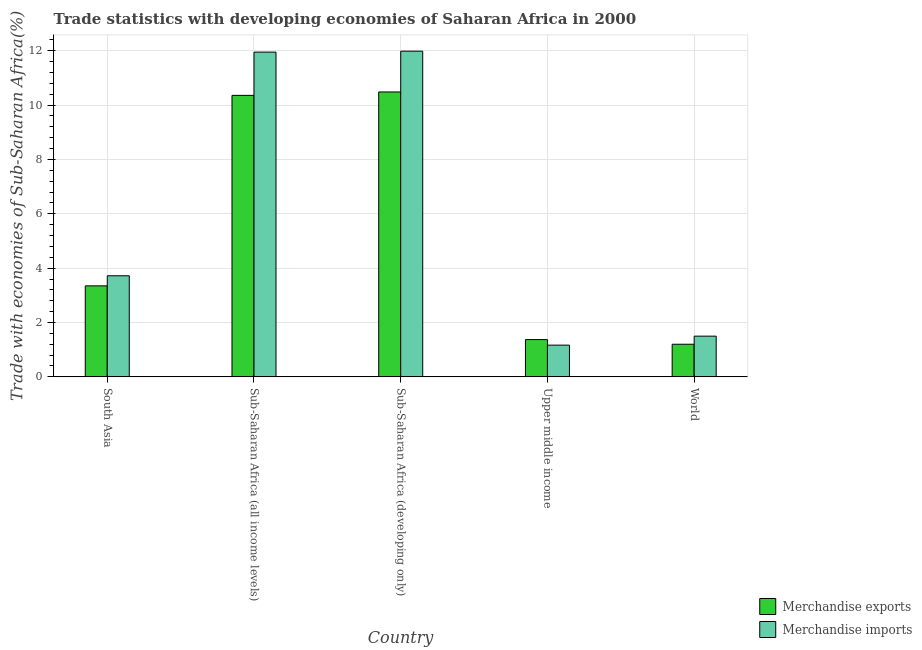How many bars are there on the 1st tick from the right?
Your answer should be very brief. 2. In how many cases, is the number of bars for a given country not equal to the number of legend labels?
Provide a succinct answer. 0. What is the merchandise exports in Sub-Saharan Africa (all income levels)?
Your answer should be very brief. 10.36. Across all countries, what is the maximum merchandise imports?
Ensure brevity in your answer.  11.98. Across all countries, what is the minimum merchandise exports?
Keep it short and to the point. 1.2. In which country was the merchandise imports maximum?
Keep it short and to the point. Sub-Saharan Africa (developing only). In which country was the merchandise exports minimum?
Keep it short and to the point. World. What is the total merchandise exports in the graph?
Offer a very short reply. 26.76. What is the difference between the merchandise imports in Sub-Saharan Africa (all income levels) and that in Sub-Saharan Africa (developing only)?
Offer a terse response. -0.03. What is the difference between the merchandise imports in Sub-Saharan Africa (developing only) and the merchandise exports in Upper middle income?
Ensure brevity in your answer.  10.61. What is the average merchandise exports per country?
Your answer should be very brief. 5.35. What is the difference between the merchandise imports and merchandise exports in Sub-Saharan Africa (developing only)?
Offer a very short reply. 1.5. In how many countries, is the merchandise imports greater than 2.8 %?
Keep it short and to the point. 3. What is the ratio of the merchandise exports in South Asia to that in Upper middle income?
Your response must be concise. 2.44. Is the merchandise exports in Sub-Saharan Africa (all income levels) less than that in Sub-Saharan Africa (developing only)?
Provide a short and direct response. Yes. Is the difference between the merchandise imports in Sub-Saharan Africa (all income levels) and Sub-Saharan Africa (developing only) greater than the difference between the merchandise exports in Sub-Saharan Africa (all income levels) and Sub-Saharan Africa (developing only)?
Your answer should be very brief. Yes. What is the difference between the highest and the second highest merchandise imports?
Keep it short and to the point. 0.03. What is the difference between the highest and the lowest merchandise exports?
Your answer should be compact. 9.28. What does the 2nd bar from the right in Sub-Saharan Africa (all income levels) represents?
Give a very brief answer. Merchandise exports. How many bars are there?
Your answer should be very brief. 10. Are all the bars in the graph horizontal?
Give a very brief answer. No. Does the graph contain any zero values?
Your answer should be compact. No. What is the title of the graph?
Offer a very short reply. Trade statistics with developing economies of Saharan Africa in 2000. Does "Girls" appear as one of the legend labels in the graph?
Ensure brevity in your answer.  No. What is the label or title of the X-axis?
Your response must be concise. Country. What is the label or title of the Y-axis?
Make the answer very short. Trade with economies of Sub-Saharan Africa(%). What is the Trade with economies of Sub-Saharan Africa(%) of Merchandise exports in South Asia?
Provide a short and direct response. 3.35. What is the Trade with economies of Sub-Saharan Africa(%) in Merchandise imports in South Asia?
Provide a succinct answer. 3.72. What is the Trade with economies of Sub-Saharan Africa(%) in Merchandise exports in Sub-Saharan Africa (all income levels)?
Keep it short and to the point. 10.36. What is the Trade with economies of Sub-Saharan Africa(%) in Merchandise imports in Sub-Saharan Africa (all income levels)?
Offer a very short reply. 11.95. What is the Trade with economies of Sub-Saharan Africa(%) of Merchandise exports in Sub-Saharan Africa (developing only)?
Keep it short and to the point. 10.48. What is the Trade with economies of Sub-Saharan Africa(%) in Merchandise imports in Sub-Saharan Africa (developing only)?
Give a very brief answer. 11.98. What is the Trade with economies of Sub-Saharan Africa(%) of Merchandise exports in Upper middle income?
Give a very brief answer. 1.37. What is the Trade with economies of Sub-Saharan Africa(%) of Merchandise imports in Upper middle income?
Offer a very short reply. 1.17. What is the Trade with economies of Sub-Saharan Africa(%) in Merchandise exports in World?
Keep it short and to the point. 1.2. What is the Trade with economies of Sub-Saharan Africa(%) of Merchandise imports in World?
Ensure brevity in your answer.  1.5. Across all countries, what is the maximum Trade with economies of Sub-Saharan Africa(%) of Merchandise exports?
Offer a very short reply. 10.48. Across all countries, what is the maximum Trade with economies of Sub-Saharan Africa(%) of Merchandise imports?
Give a very brief answer. 11.98. Across all countries, what is the minimum Trade with economies of Sub-Saharan Africa(%) of Merchandise exports?
Keep it short and to the point. 1.2. Across all countries, what is the minimum Trade with economies of Sub-Saharan Africa(%) in Merchandise imports?
Your response must be concise. 1.17. What is the total Trade with economies of Sub-Saharan Africa(%) in Merchandise exports in the graph?
Your answer should be very brief. 26.76. What is the total Trade with economies of Sub-Saharan Africa(%) of Merchandise imports in the graph?
Offer a very short reply. 30.32. What is the difference between the Trade with economies of Sub-Saharan Africa(%) of Merchandise exports in South Asia and that in Sub-Saharan Africa (all income levels)?
Provide a succinct answer. -7.01. What is the difference between the Trade with economies of Sub-Saharan Africa(%) of Merchandise imports in South Asia and that in Sub-Saharan Africa (all income levels)?
Provide a succinct answer. -8.23. What is the difference between the Trade with economies of Sub-Saharan Africa(%) of Merchandise exports in South Asia and that in Sub-Saharan Africa (developing only)?
Make the answer very short. -7.13. What is the difference between the Trade with economies of Sub-Saharan Africa(%) of Merchandise imports in South Asia and that in Sub-Saharan Africa (developing only)?
Give a very brief answer. -8.26. What is the difference between the Trade with economies of Sub-Saharan Africa(%) in Merchandise exports in South Asia and that in Upper middle income?
Give a very brief answer. 1.98. What is the difference between the Trade with economies of Sub-Saharan Africa(%) of Merchandise imports in South Asia and that in Upper middle income?
Your response must be concise. 2.55. What is the difference between the Trade with economies of Sub-Saharan Africa(%) in Merchandise exports in South Asia and that in World?
Your answer should be very brief. 2.15. What is the difference between the Trade with economies of Sub-Saharan Africa(%) in Merchandise imports in South Asia and that in World?
Offer a terse response. 2.22. What is the difference between the Trade with economies of Sub-Saharan Africa(%) of Merchandise exports in Sub-Saharan Africa (all income levels) and that in Sub-Saharan Africa (developing only)?
Your answer should be compact. -0.13. What is the difference between the Trade with economies of Sub-Saharan Africa(%) of Merchandise imports in Sub-Saharan Africa (all income levels) and that in Sub-Saharan Africa (developing only)?
Your response must be concise. -0.04. What is the difference between the Trade with economies of Sub-Saharan Africa(%) in Merchandise exports in Sub-Saharan Africa (all income levels) and that in Upper middle income?
Provide a short and direct response. 8.98. What is the difference between the Trade with economies of Sub-Saharan Africa(%) of Merchandise imports in Sub-Saharan Africa (all income levels) and that in Upper middle income?
Offer a very short reply. 10.78. What is the difference between the Trade with economies of Sub-Saharan Africa(%) of Merchandise exports in Sub-Saharan Africa (all income levels) and that in World?
Provide a short and direct response. 9.16. What is the difference between the Trade with economies of Sub-Saharan Africa(%) in Merchandise imports in Sub-Saharan Africa (all income levels) and that in World?
Keep it short and to the point. 10.45. What is the difference between the Trade with economies of Sub-Saharan Africa(%) of Merchandise exports in Sub-Saharan Africa (developing only) and that in Upper middle income?
Provide a short and direct response. 9.11. What is the difference between the Trade with economies of Sub-Saharan Africa(%) in Merchandise imports in Sub-Saharan Africa (developing only) and that in Upper middle income?
Your answer should be very brief. 10.82. What is the difference between the Trade with economies of Sub-Saharan Africa(%) of Merchandise exports in Sub-Saharan Africa (developing only) and that in World?
Provide a short and direct response. 9.28. What is the difference between the Trade with economies of Sub-Saharan Africa(%) of Merchandise imports in Sub-Saharan Africa (developing only) and that in World?
Keep it short and to the point. 10.48. What is the difference between the Trade with economies of Sub-Saharan Africa(%) in Merchandise exports in Upper middle income and that in World?
Offer a terse response. 0.17. What is the difference between the Trade with economies of Sub-Saharan Africa(%) of Merchandise imports in Upper middle income and that in World?
Provide a short and direct response. -0.33. What is the difference between the Trade with economies of Sub-Saharan Africa(%) of Merchandise exports in South Asia and the Trade with economies of Sub-Saharan Africa(%) of Merchandise imports in Sub-Saharan Africa (all income levels)?
Provide a succinct answer. -8.6. What is the difference between the Trade with economies of Sub-Saharan Africa(%) in Merchandise exports in South Asia and the Trade with economies of Sub-Saharan Africa(%) in Merchandise imports in Sub-Saharan Africa (developing only)?
Provide a short and direct response. -8.63. What is the difference between the Trade with economies of Sub-Saharan Africa(%) of Merchandise exports in South Asia and the Trade with economies of Sub-Saharan Africa(%) of Merchandise imports in Upper middle income?
Ensure brevity in your answer.  2.18. What is the difference between the Trade with economies of Sub-Saharan Africa(%) of Merchandise exports in South Asia and the Trade with economies of Sub-Saharan Africa(%) of Merchandise imports in World?
Your answer should be compact. 1.85. What is the difference between the Trade with economies of Sub-Saharan Africa(%) of Merchandise exports in Sub-Saharan Africa (all income levels) and the Trade with economies of Sub-Saharan Africa(%) of Merchandise imports in Sub-Saharan Africa (developing only)?
Offer a very short reply. -1.63. What is the difference between the Trade with economies of Sub-Saharan Africa(%) of Merchandise exports in Sub-Saharan Africa (all income levels) and the Trade with economies of Sub-Saharan Africa(%) of Merchandise imports in Upper middle income?
Make the answer very short. 9.19. What is the difference between the Trade with economies of Sub-Saharan Africa(%) of Merchandise exports in Sub-Saharan Africa (all income levels) and the Trade with economies of Sub-Saharan Africa(%) of Merchandise imports in World?
Provide a succinct answer. 8.86. What is the difference between the Trade with economies of Sub-Saharan Africa(%) of Merchandise exports in Sub-Saharan Africa (developing only) and the Trade with economies of Sub-Saharan Africa(%) of Merchandise imports in Upper middle income?
Your answer should be very brief. 9.31. What is the difference between the Trade with economies of Sub-Saharan Africa(%) in Merchandise exports in Sub-Saharan Africa (developing only) and the Trade with economies of Sub-Saharan Africa(%) in Merchandise imports in World?
Give a very brief answer. 8.98. What is the difference between the Trade with economies of Sub-Saharan Africa(%) of Merchandise exports in Upper middle income and the Trade with economies of Sub-Saharan Africa(%) of Merchandise imports in World?
Offer a very short reply. -0.13. What is the average Trade with economies of Sub-Saharan Africa(%) of Merchandise exports per country?
Ensure brevity in your answer.  5.35. What is the average Trade with economies of Sub-Saharan Africa(%) of Merchandise imports per country?
Provide a succinct answer. 6.06. What is the difference between the Trade with economies of Sub-Saharan Africa(%) in Merchandise exports and Trade with economies of Sub-Saharan Africa(%) in Merchandise imports in South Asia?
Your response must be concise. -0.37. What is the difference between the Trade with economies of Sub-Saharan Africa(%) of Merchandise exports and Trade with economies of Sub-Saharan Africa(%) of Merchandise imports in Sub-Saharan Africa (all income levels)?
Ensure brevity in your answer.  -1.59. What is the difference between the Trade with economies of Sub-Saharan Africa(%) of Merchandise exports and Trade with economies of Sub-Saharan Africa(%) of Merchandise imports in Sub-Saharan Africa (developing only)?
Your answer should be very brief. -1.5. What is the difference between the Trade with economies of Sub-Saharan Africa(%) of Merchandise exports and Trade with economies of Sub-Saharan Africa(%) of Merchandise imports in Upper middle income?
Provide a short and direct response. 0.2. What is the difference between the Trade with economies of Sub-Saharan Africa(%) of Merchandise exports and Trade with economies of Sub-Saharan Africa(%) of Merchandise imports in World?
Make the answer very short. -0.3. What is the ratio of the Trade with economies of Sub-Saharan Africa(%) in Merchandise exports in South Asia to that in Sub-Saharan Africa (all income levels)?
Offer a very short reply. 0.32. What is the ratio of the Trade with economies of Sub-Saharan Africa(%) in Merchandise imports in South Asia to that in Sub-Saharan Africa (all income levels)?
Offer a terse response. 0.31. What is the ratio of the Trade with economies of Sub-Saharan Africa(%) in Merchandise exports in South Asia to that in Sub-Saharan Africa (developing only)?
Offer a terse response. 0.32. What is the ratio of the Trade with economies of Sub-Saharan Africa(%) of Merchandise imports in South Asia to that in Sub-Saharan Africa (developing only)?
Provide a short and direct response. 0.31. What is the ratio of the Trade with economies of Sub-Saharan Africa(%) in Merchandise exports in South Asia to that in Upper middle income?
Your answer should be compact. 2.44. What is the ratio of the Trade with economies of Sub-Saharan Africa(%) of Merchandise imports in South Asia to that in Upper middle income?
Give a very brief answer. 3.19. What is the ratio of the Trade with economies of Sub-Saharan Africa(%) in Merchandise exports in South Asia to that in World?
Provide a succinct answer. 2.79. What is the ratio of the Trade with economies of Sub-Saharan Africa(%) in Merchandise imports in South Asia to that in World?
Your answer should be compact. 2.48. What is the ratio of the Trade with economies of Sub-Saharan Africa(%) of Merchandise exports in Sub-Saharan Africa (all income levels) to that in Sub-Saharan Africa (developing only)?
Your answer should be compact. 0.99. What is the ratio of the Trade with economies of Sub-Saharan Africa(%) in Merchandise imports in Sub-Saharan Africa (all income levels) to that in Sub-Saharan Africa (developing only)?
Your answer should be compact. 1. What is the ratio of the Trade with economies of Sub-Saharan Africa(%) of Merchandise exports in Sub-Saharan Africa (all income levels) to that in Upper middle income?
Keep it short and to the point. 7.55. What is the ratio of the Trade with economies of Sub-Saharan Africa(%) in Merchandise imports in Sub-Saharan Africa (all income levels) to that in Upper middle income?
Provide a succinct answer. 10.23. What is the ratio of the Trade with economies of Sub-Saharan Africa(%) of Merchandise exports in Sub-Saharan Africa (all income levels) to that in World?
Give a very brief answer. 8.63. What is the ratio of the Trade with economies of Sub-Saharan Africa(%) of Merchandise imports in Sub-Saharan Africa (all income levels) to that in World?
Your response must be concise. 7.98. What is the ratio of the Trade with economies of Sub-Saharan Africa(%) of Merchandise exports in Sub-Saharan Africa (developing only) to that in Upper middle income?
Keep it short and to the point. 7.64. What is the ratio of the Trade with economies of Sub-Saharan Africa(%) of Merchandise imports in Sub-Saharan Africa (developing only) to that in Upper middle income?
Provide a short and direct response. 10.26. What is the ratio of the Trade with economies of Sub-Saharan Africa(%) in Merchandise exports in Sub-Saharan Africa (developing only) to that in World?
Make the answer very short. 8.73. What is the ratio of the Trade with economies of Sub-Saharan Africa(%) of Merchandise imports in Sub-Saharan Africa (developing only) to that in World?
Make the answer very short. 8. What is the ratio of the Trade with economies of Sub-Saharan Africa(%) in Merchandise exports in Upper middle income to that in World?
Make the answer very short. 1.14. What is the ratio of the Trade with economies of Sub-Saharan Africa(%) in Merchandise imports in Upper middle income to that in World?
Give a very brief answer. 0.78. What is the difference between the highest and the second highest Trade with economies of Sub-Saharan Africa(%) in Merchandise exports?
Ensure brevity in your answer.  0.13. What is the difference between the highest and the second highest Trade with economies of Sub-Saharan Africa(%) in Merchandise imports?
Offer a terse response. 0.04. What is the difference between the highest and the lowest Trade with economies of Sub-Saharan Africa(%) in Merchandise exports?
Your answer should be compact. 9.28. What is the difference between the highest and the lowest Trade with economies of Sub-Saharan Africa(%) of Merchandise imports?
Your answer should be compact. 10.82. 